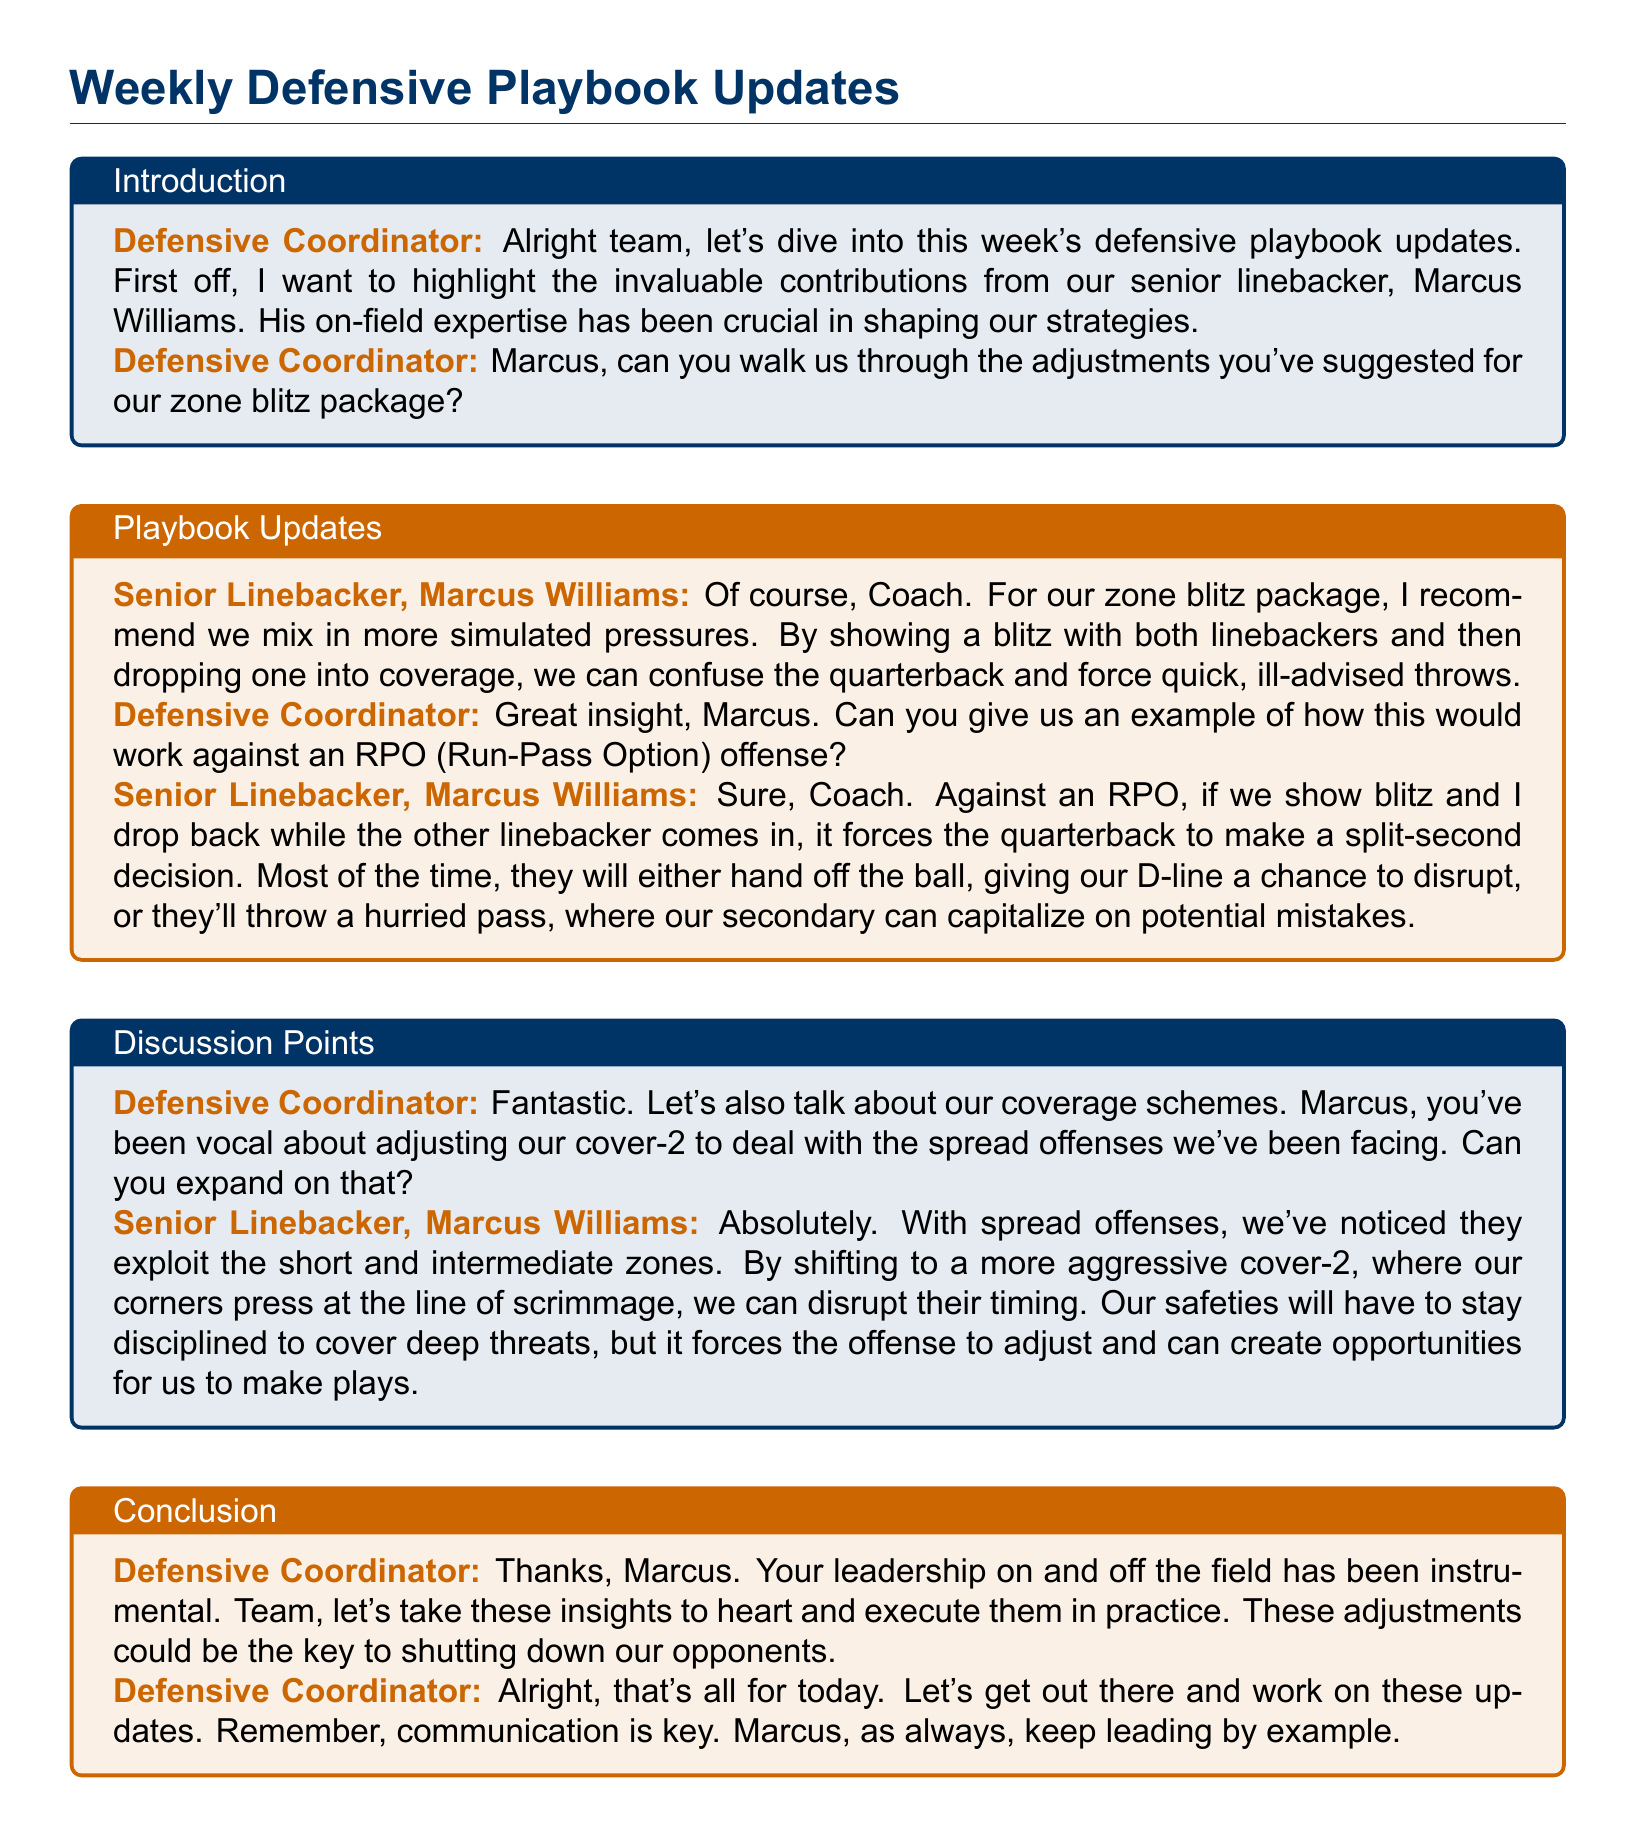What is the name of the senior linebacker? The document identifies the senior linebacker as Marcus Williams.
Answer: Marcus Williams What is the primary focus of the weekly update? The updates focus on contributions and insights from senior linebacker Marcus Williams regarding defensive strategies.
Answer: Defensive strategies What package adjustment does Marcus recommend? Marcus suggests mixing in more simulated pressures for the zone blitz package.
Answer: Simulated pressures What offensive strategy does Marcus provide an example against? Marcus provides an example against an RPO (Run-Pass Option) offense.
Answer: RPO What coverage adjustment has Marcus been vocal about? Marcus has been vocal about adjusting the cover-2 to deal with spread offenses.
Answer: Cover-2 What does Marcus say they can disrupt by pressing at the line of scrimmage? By pressing at the line, they can disrupt the timing of the spread offense.
Answer: Timing Who leads the discussion in the document? The defensive coordinator leads the discussion throughout the document.
Answer: Defensive coordinator What does the defensive coordinator emphasize at the end of the meeting? The defensive coordinator emphasizes that communication is key as they execute the updates.
Answer: Communication 